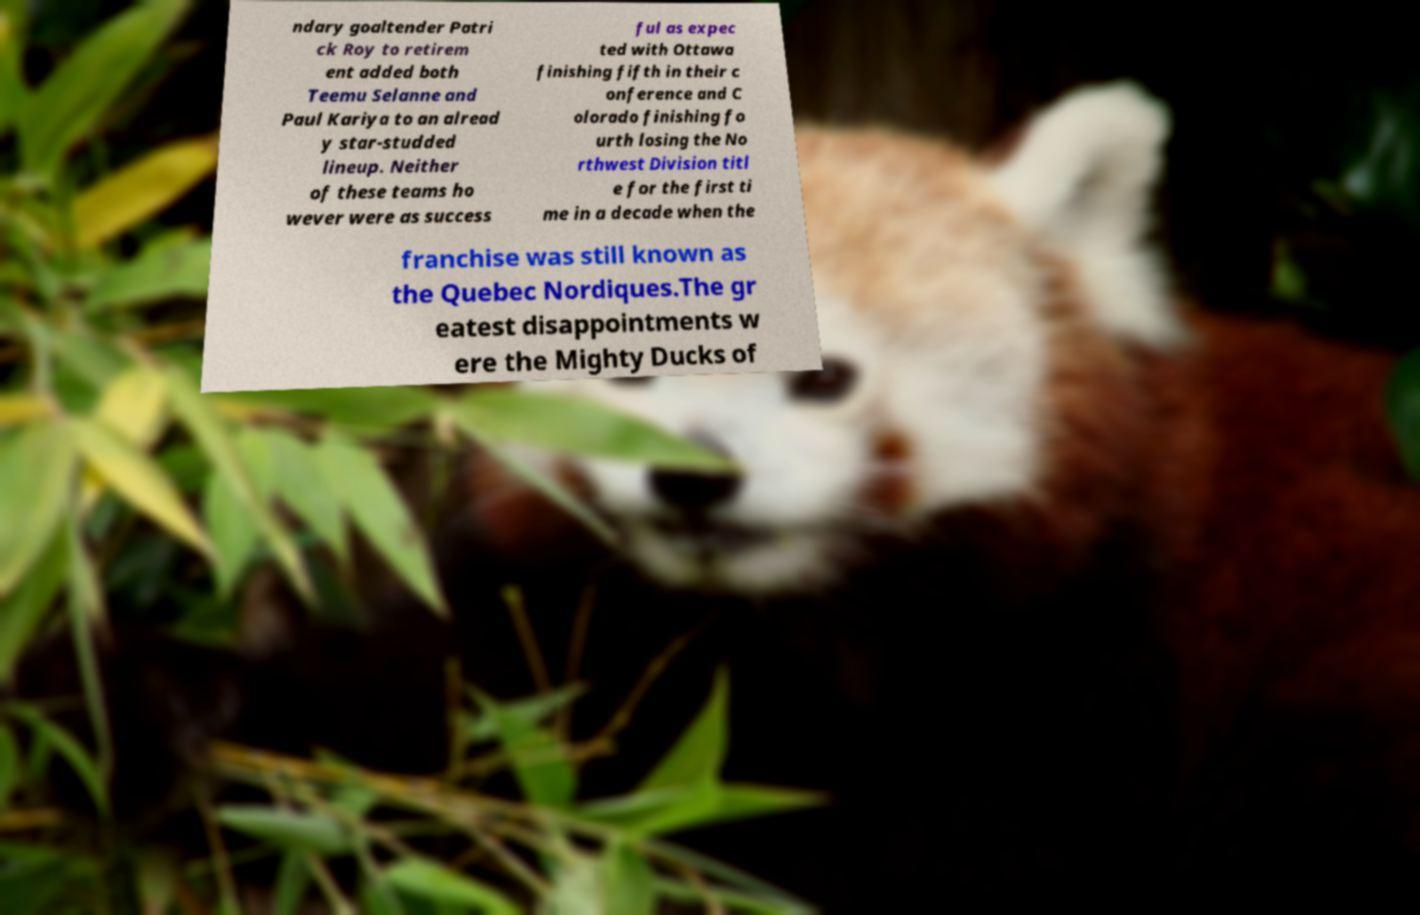Please identify and transcribe the text found in this image. ndary goaltender Patri ck Roy to retirem ent added both Teemu Selanne and Paul Kariya to an alread y star-studded lineup. Neither of these teams ho wever were as success ful as expec ted with Ottawa finishing fifth in their c onference and C olorado finishing fo urth losing the No rthwest Division titl e for the first ti me in a decade when the franchise was still known as the Quebec Nordiques.The gr eatest disappointments w ere the Mighty Ducks of 